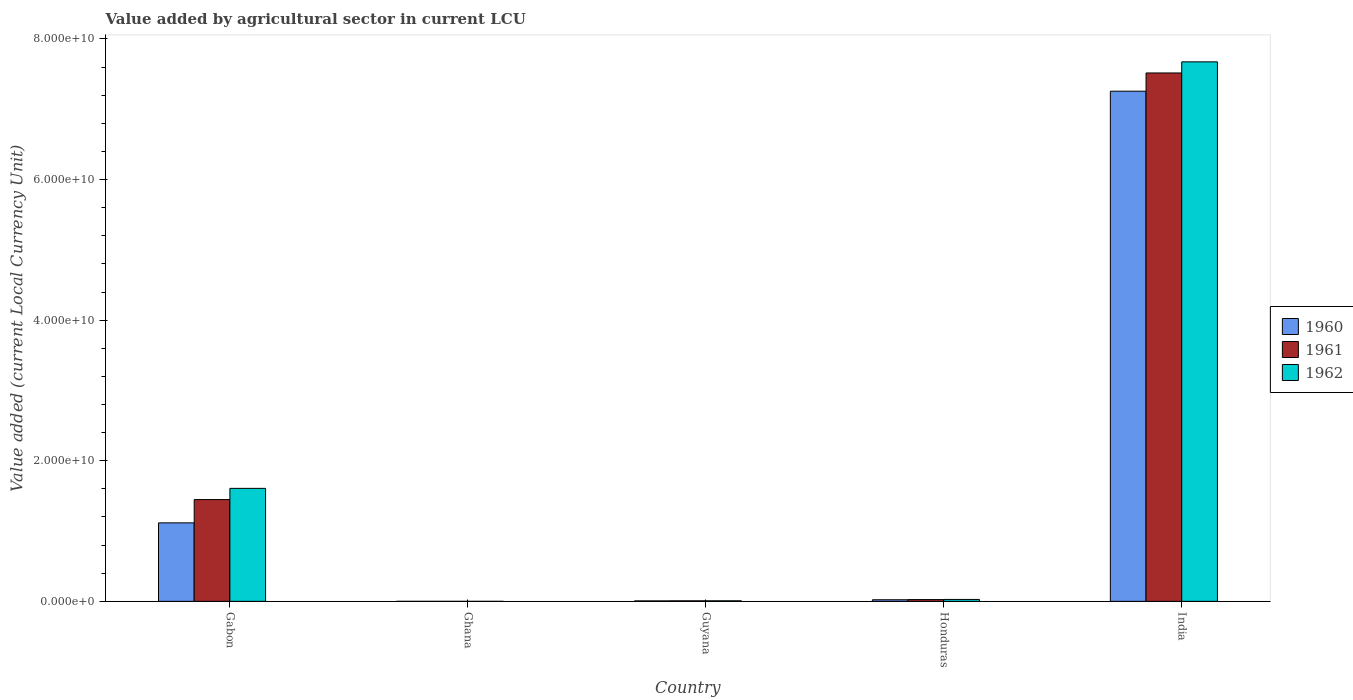Are the number of bars per tick equal to the number of legend labels?
Offer a very short reply. Yes. Are the number of bars on each tick of the X-axis equal?
Keep it short and to the point. Yes. What is the label of the 1st group of bars from the left?
Give a very brief answer. Gabon. In how many cases, is the number of bars for a given country not equal to the number of legend labels?
Ensure brevity in your answer.  0. What is the value added by agricultural sector in 1960 in Guyana?
Make the answer very short. 6.88e+07. Across all countries, what is the maximum value added by agricultural sector in 1961?
Your answer should be very brief. 7.52e+1. Across all countries, what is the minimum value added by agricultural sector in 1962?
Offer a very short reply. 3.74e+04. What is the total value added by agricultural sector in 1961 in the graph?
Your response must be concise. 9.00e+1. What is the difference between the value added by agricultural sector in 1961 in Ghana and that in Guyana?
Provide a short and direct response. -7.60e+07. What is the difference between the value added by agricultural sector in 1962 in India and the value added by agricultural sector in 1961 in Guyana?
Give a very brief answer. 7.67e+1. What is the average value added by agricultural sector in 1960 per country?
Provide a succinct answer. 1.68e+1. What is the difference between the value added by agricultural sector of/in 1962 and value added by agricultural sector of/in 1961 in Guyana?
Ensure brevity in your answer.  2.40e+06. In how many countries, is the value added by agricultural sector in 1960 greater than 24000000000 LCU?
Your answer should be very brief. 1. What is the ratio of the value added by agricultural sector in 1960 in Gabon to that in Honduras?
Offer a very short reply. 49.18. Is the value added by agricultural sector in 1960 in Ghana less than that in Guyana?
Ensure brevity in your answer.  Yes. Is the difference between the value added by agricultural sector in 1962 in Gabon and Ghana greater than the difference between the value added by agricultural sector in 1961 in Gabon and Ghana?
Offer a terse response. Yes. What is the difference between the highest and the second highest value added by agricultural sector in 1962?
Your answer should be compact. 6.07e+1. What is the difference between the highest and the lowest value added by agricultural sector in 1962?
Provide a short and direct response. 7.67e+1. In how many countries, is the value added by agricultural sector in 1960 greater than the average value added by agricultural sector in 1960 taken over all countries?
Offer a very short reply. 1. Is the sum of the value added by agricultural sector in 1960 in Guyana and India greater than the maximum value added by agricultural sector in 1962 across all countries?
Your answer should be compact. No. What does the 3rd bar from the left in Honduras represents?
Your answer should be very brief. 1962. Is it the case that in every country, the sum of the value added by agricultural sector in 1962 and value added by agricultural sector in 1960 is greater than the value added by agricultural sector in 1961?
Your answer should be compact. Yes. How many bars are there?
Your answer should be compact. 15. Are all the bars in the graph horizontal?
Keep it short and to the point. No. How many countries are there in the graph?
Ensure brevity in your answer.  5. Are the values on the major ticks of Y-axis written in scientific E-notation?
Make the answer very short. Yes. Does the graph contain grids?
Provide a succinct answer. No. How many legend labels are there?
Your answer should be compact. 3. What is the title of the graph?
Your response must be concise. Value added by agricultural sector in current LCU. Does "2011" appear as one of the legend labels in the graph?
Ensure brevity in your answer.  No. What is the label or title of the Y-axis?
Your answer should be compact. Value added (current Local Currency Unit). What is the Value added (current Local Currency Unit) of 1960 in Gabon?
Provide a short and direct response. 1.12e+1. What is the Value added (current Local Currency Unit) of 1961 in Gabon?
Provide a short and direct response. 1.45e+1. What is the Value added (current Local Currency Unit) of 1962 in Gabon?
Provide a short and direct response. 1.61e+1. What is the Value added (current Local Currency Unit) in 1960 in Ghana?
Provide a short and direct response. 3.55e+04. What is the Value added (current Local Currency Unit) in 1961 in Ghana?
Your response must be concise. 3.29e+04. What is the Value added (current Local Currency Unit) of 1962 in Ghana?
Your answer should be very brief. 3.74e+04. What is the Value added (current Local Currency Unit) of 1960 in Guyana?
Offer a terse response. 6.88e+07. What is the Value added (current Local Currency Unit) in 1961 in Guyana?
Provide a short and direct response. 7.60e+07. What is the Value added (current Local Currency Unit) of 1962 in Guyana?
Keep it short and to the point. 7.84e+07. What is the Value added (current Local Currency Unit) in 1960 in Honduras?
Provide a short and direct response. 2.27e+08. What is the Value added (current Local Currency Unit) in 1961 in Honduras?
Your answer should be compact. 2.51e+08. What is the Value added (current Local Currency Unit) of 1962 in Honduras?
Ensure brevity in your answer.  2.74e+08. What is the Value added (current Local Currency Unit) of 1960 in India?
Provide a succinct answer. 7.26e+1. What is the Value added (current Local Currency Unit) in 1961 in India?
Make the answer very short. 7.52e+1. What is the Value added (current Local Currency Unit) of 1962 in India?
Make the answer very short. 7.67e+1. Across all countries, what is the maximum Value added (current Local Currency Unit) in 1960?
Offer a terse response. 7.26e+1. Across all countries, what is the maximum Value added (current Local Currency Unit) in 1961?
Your response must be concise. 7.52e+1. Across all countries, what is the maximum Value added (current Local Currency Unit) in 1962?
Ensure brevity in your answer.  7.67e+1. Across all countries, what is the minimum Value added (current Local Currency Unit) of 1960?
Provide a succinct answer. 3.55e+04. Across all countries, what is the minimum Value added (current Local Currency Unit) in 1961?
Provide a short and direct response. 3.29e+04. Across all countries, what is the minimum Value added (current Local Currency Unit) of 1962?
Your answer should be compact. 3.74e+04. What is the total Value added (current Local Currency Unit) of 1960 in the graph?
Offer a very short reply. 8.40e+1. What is the total Value added (current Local Currency Unit) in 1961 in the graph?
Your response must be concise. 9.00e+1. What is the total Value added (current Local Currency Unit) in 1962 in the graph?
Make the answer very short. 9.32e+1. What is the difference between the Value added (current Local Currency Unit) of 1960 in Gabon and that in Ghana?
Make the answer very short. 1.12e+1. What is the difference between the Value added (current Local Currency Unit) of 1961 in Gabon and that in Ghana?
Your answer should be very brief. 1.45e+1. What is the difference between the Value added (current Local Currency Unit) in 1962 in Gabon and that in Ghana?
Give a very brief answer. 1.61e+1. What is the difference between the Value added (current Local Currency Unit) in 1960 in Gabon and that in Guyana?
Provide a short and direct response. 1.11e+1. What is the difference between the Value added (current Local Currency Unit) in 1961 in Gabon and that in Guyana?
Your response must be concise. 1.44e+1. What is the difference between the Value added (current Local Currency Unit) in 1962 in Gabon and that in Guyana?
Keep it short and to the point. 1.60e+1. What is the difference between the Value added (current Local Currency Unit) of 1960 in Gabon and that in Honduras?
Provide a succinct answer. 1.09e+1. What is the difference between the Value added (current Local Currency Unit) of 1961 in Gabon and that in Honduras?
Keep it short and to the point. 1.42e+1. What is the difference between the Value added (current Local Currency Unit) of 1962 in Gabon and that in Honduras?
Offer a very short reply. 1.58e+1. What is the difference between the Value added (current Local Currency Unit) in 1960 in Gabon and that in India?
Offer a very short reply. -6.14e+1. What is the difference between the Value added (current Local Currency Unit) in 1961 in Gabon and that in India?
Provide a succinct answer. -6.07e+1. What is the difference between the Value added (current Local Currency Unit) in 1962 in Gabon and that in India?
Give a very brief answer. -6.07e+1. What is the difference between the Value added (current Local Currency Unit) in 1960 in Ghana and that in Guyana?
Make the answer very short. -6.88e+07. What is the difference between the Value added (current Local Currency Unit) of 1961 in Ghana and that in Guyana?
Make the answer very short. -7.60e+07. What is the difference between the Value added (current Local Currency Unit) in 1962 in Ghana and that in Guyana?
Your response must be concise. -7.84e+07. What is the difference between the Value added (current Local Currency Unit) of 1960 in Ghana and that in Honduras?
Ensure brevity in your answer.  -2.27e+08. What is the difference between the Value added (current Local Currency Unit) of 1961 in Ghana and that in Honduras?
Keep it short and to the point. -2.51e+08. What is the difference between the Value added (current Local Currency Unit) of 1962 in Ghana and that in Honduras?
Make the answer very short. -2.74e+08. What is the difference between the Value added (current Local Currency Unit) in 1960 in Ghana and that in India?
Your response must be concise. -7.26e+1. What is the difference between the Value added (current Local Currency Unit) of 1961 in Ghana and that in India?
Offer a terse response. -7.52e+1. What is the difference between the Value added (current Local Currency Unit) in 1962 in Ghana and that in India?
Offer a very short reply. -7.67e+1. What is the difference between the Value added (current Local Currency Unit) of 1960 in Guyana and that in Honduras?
Provide a short and direct response. -1.58e+08. What is the difference between the Value added (current Local Currency Unit) in 1961 in Guyana and that in Honduras?
Offer a very short reply. -1.75e+08. What is the difference between the Value added (current Local Currency Unit) in 1962 in Guyana and that in Honduras?
Offer a very short reply. -1.96e+08. What is the difference between the Value added (current Local Currency Unit) of 1960 in Guyana and that in India?
Offer a terse response. -7.25e+1. What is the difference between the Value added (current Local Currency Unit) of 1961 in Guyana and that in India?
Provide a succinct answer. -7.51e+1. What is the difference between the Value added (current Local Currency Unit) in 1962 in Guyana and that in India?
Ensure brevity in your answer.  -7.67e+1. What is the difference between the Value added (current Local Currency Unit) of 1960 in Honduras and that in India?
Your answer should be compact. -7.23e+1. What is the difference between the Value added (current Local Currency Unit) in 1961 in Honduras and that in India?
Keep it short and to the point. -7.49e+1. What is the difference between the Value added (current Local Currency Unit) in 1962 in Honduras and that in India?
Offer a terse response. -7.65e+1. What is the difference between the Value added (current Local Currency Unit) in 1960 in Gabon and the Value added (current Local Currency Unit) in 1961 in Ghana?
Offer a terse response. 1.12e+1. What is the difference between the Value added (current Local Currency Unit) in 1960 in Gabon and the Value added (current Local Currency Unit) in 1962 in Ghana?
Provide a succinct answer. 1.12e+1. What is the difference between the Value added (current Local Currency Unit) of 1961 in Gabon and the Value added (current Local Currency Unit) of 1962 in Ghana?
Make the answer very short. 1.45e+1. What is the difference between the Value added (current Local Currency Unit) of 1960 in Gabon and the Value added (current Local Currency Unit) of 1961 in Guyana?
Offer a very short reply. 1.11e+1. What is the difference between the Value added (current Local Currency Unit) of 1960 in Gabon and the Value added (current Local Currency Unit) of 1962 in Guyana?
Your answer should be very brief. 1.11e+1. What is the difference between the Value added (current Local Currency Unit) of 1961 in Gabon and the Value added (current Local Currency Unit) of 1962 in Guyana?
Offer a terse response. 1.44e+1. What is the difference between the Value added (current Local Currency Unit) in 1960 in Gabon and the Value added (current Local Currency Unit) in 1961 in Honduras?
Ensure brevity in your answer.  1.09e+1. What is the difference between the Value added (current Local Currency Unit) of 1960 in Gabon and the Value added (current Local Currency Unit) of 1962 in Honduras?
Offer a terse response. 1.09e+1. What is the difference between the Value added (current Local Currency Unit) in 1961 in Gabon and the Value added (current Local Currency Unit) in 1962 in Honduras?
Your answer should be compact. 1.42e+1. What is the difference between the Value added (current Local Currency Unit) in 1960 in Gabon and the Value added (current Local Currency Unit) in 1961 in India?
Your answer should be compact. -6.40e+1. What is the difference between the Value added (current Local Currency Unit) of 1960 in Gabon and the Value added (current Local Currency Unit) of 1962 in India?
Your answer should be compact. -6.56e+1. What is the difference between the Value added (current Local Currency Unit) in 1961 in Gabon and the Value added (current Local Currency Unit) in 1962 in India?
Your response must be concise. -6.23e+1. What is the difference between the Value added (current Local Currency Unit) of 1960 in Ghana and the Value added (current Local Currency Unit) of 1961 in Guyana?
Keep it short and to the point. -7.60e+07. What is the difference between the Value added (current Local Currency Unit) in 1960 in Ghana and the Value added (current Local Currency Unit) in 1962 in Guyana?
Provide a short and direct response. -7.84e+07. What is the difference between the Value added (current Local Currency Unit) in 1961 in Ghana and the Value added (current Local Currency Unit) in 1962 in Guyana?
Offer a very short reply. -7.84e+07. What is the difference between the Value added (current Local Currency Unit) in 1960 in Ghana and the Value added (current Local Currency Unit) in 1961 in Honduras?
Offer a terse response. -2.51e+08. What is the difference between the Value added (current Local Currency Unit) of 1960 in Ghana and the Value added (current Local Currency Unit) of 1962 in Honduras?
Provide a short and direct response. -2.74e+08. What is the difference between the Value added (current Local Currency Unit) of 1961 in Ghana and the Value added (current Local Currency Unit) of 1962 in Honduras?
Your answer should be compact. -2.74e+08. What is the difference between the Value added (current Local Currency Unit) of 1960 in Ghana and the Value added (current Local Currency Unit) of 1961 in India?
Your response must be concise. -7.52e+1. What is the difference between the Value added (current Local Currency Unit) in 1960 in Ghana and the Value added (current Local Currency Unit) in 1962 in India?
Your answer should be compact. -7.67e+1. What is the difference between the Value added (current Local Currency Unit) in 1961 in Ghana and the Value added (current Local Currency Unit) in 1962 in India?
Your answer should be compact. -7.67e+1. What is the difference between the Value added (current Local Currency Unit) in 1960 in Guyana and the Value added (current Local Currency Unit) in 1961 in Honduras?
Provide a short and direct response. -1.82e+08. What is the difference between the Value added (current Local Currency Unit) of 1960 in Guyana and the Value added (current Local Currency Unit) of 1962 in Honduras?
Keep it short and to the point. -2.06e+08. What is the difference between the Value added (current Local Currency Unit) of 1961 in Guyana and the Value added (current Local Currency Unit) of 1962 in Honduras?
Give a very brief answer. -1.98e+08. What is the difference between the Value added (current Local Currency Unit) in 1960 in Guyana and the Value added (current Local Currency Unit) in 1961 in India?
Your answer should be compact. -7.51e+1. What is the difference between the Value added (current Local Currency Unit) in 1960 in Guyana and the Value added (current Local Currency Unit) in 1962 in India?
Your answer should be very brief. -7.67e+1. What is the difference between the Value added (current Local Currency Unit) of 1961 in Guyana and the Value added (current Local Currency Unit) of 1962 in India?
Your answer should be very brief. -7.67e+1. What is the difference between the Value added (current Local Currency Unit) in 1960 in Honduras and the Value added (current Local Currency Unit) in 1961 in India?
Your answer should be compact. -7.49e+1. What is the difference between the Value added (current Local Currency Unit) of 1960 in Honduras and the Value added (current Local Currency Unit) of 1962 in India?
Make the answer very short. -7.65e+1. What is the difference between the Value added (current Local Currency Unit) in 1961 in Honduras and the Value added (current Local Currency Unit) in 1962 in India?
Provide a short and direct response. -7.65e+1. What is the average Value added (current Local Currency Unit) in 1960 per country?
Offer a terse response. 1.68e+1. What is the average Value added (current Local Currency Unit) of 1961 per country?
Your answer should be compact. 1.80e+1. What is the average Value added (current Local Currency Unit) of 1962 per country?
Your answer should be compact. 1.86e+1. What is the difference between the Value added (current Local Currency Unit) in 1960 and Value added (current Local Currency Unit) in 1961 in Gabon?
Make the answer very short. -3.31e+09. What is the difference between the Value added (current Local Currency Unit) in 1960 and Value added (current Local Currency Unit) in 1962 in Gabon?
Your answer should be very brief. -4.91e+09. What is the difference between the Value added (current Local Currency Unit) in 1961 and Value added (current Local Currency Unit) in 1962 in Gabon?
Offer a very short reply. -1.59e+09. What is the difference between the Value added (current Local Currency Unit) of 1960 and Value added (current Local Currency Unit) of 1961 in Ghana?
Make the answer very short. 2600. What is the difference between the Value added (current Local Currency Unit) of 1960 and Value added (current Local Currency Unit) of 1962 in Ghana?
Your answer should be very brief. -1900. What is the difference between the Value added (current Local Currency Unit) in 1961 and Value added (current Local Currency Unit) in 1962 in Ghana?
Your answer should be very brief. -4500. What is the difference between the Value added (current Local Currency Unit) of 1960 and Value added (current Local Currency Unit) of 1961 in Guyana?
Provide a short and direct response. -7.20e+06. What is the difference between the Value added (current Local Currency Unit) of 1960 and Value added (current Local Currency Unit) of 1962 in Guyana?
Your answer should be very brief. -9.60e+06. What is the difference between the Value added (current Local Currency Unit) in 1961 and Value added (current Local Currency Unit) in 1962 in Guyana?
Ensure brevity in your answer.  -2.40e+06. What is the difference between the Value added (current Local Currency Unit) of 1960 and Value added (current Local Currency Unit) of 1961 in Honduras?
Provide a short and direct response. -2.42e+07. What is the difference between the Value added (current Local Currency Unit) in 1960 and Value added (current Local Currency Unit) in 1962 in Honduras?
Keep it short and to the point. -4.75e+07. What is the difference between the Value added (current Local Currency Unit) in 1961 and Value added (current Local Currency Unit) in 1962 in Honduras?
Offer a terse response. -2.33e+07. What is the difference between the Value added (current Local Currency Unit) of 1960 and Value added (current Local Currency Unit) of 1961 in India?
Your answer should be very brief. -2.59e+09. What is the difference between the Value added (current Local Currency Unit) in 1960 and Value added (current Local Currency Unit) in 1962 in India?
Provide a short and direct response. -4.17e+09. What is the difference between the Value added (current Local Currency Unit) of 1961 and Value added (current Local Currency Unit) of 1962 in India?
Give a very brief answer. -1.58e+09. What is the ratio of the Value added (current Local Currency Unit) in 1960 in Gabon to that in Ghana?
Provide a succinct answer. 3.14e+05. What is the ratio of the Value added (current Local Currency Unit) in 1961 in Gabon to that in Ghana?
Provide a short and direct response. 4.40e+05. What is the ratio of the Value added (current Local Currency Unit) of 1962 in Gabon to that in Ghana?
Your answer should be very brief. 4.30e+05. What is the ratio of the Value added (current Local Currency Unit) of 1960 in Gabon to that in Guyana?
Keep it short and to the point. 162.28. What is the ratio of the Value added (current Local Currency Unit) of 1961 in Gabon to that in Guyana?
Make the answer very short. 190.49. What is the ratio of the Value added (current Local Currency Unit) in 1962 in Gabon to that in Guyana?
Make the answer very short. 205. What is the ratio of the Value added (current Local Currency Unit) of 1960 in Gabon to that in Honduras?
Ensure brevity in your answer.  49.18. What is the ratio of the Value added (current Local Currency Unit) of 1961 in Gabon to that in Honduras?
Keep it short and to the point. 57.63. What is the ratio of the Value added (current Local Currency Unit) in 1962 in Gabon to that in Honduras?
Offer a very short reply. 58.55. What is the ratio of the Value added (current Local Currency Unit) in 1960 in Gabon to that in India?
Provide a short and direct response. 0.15. What is the ratio of the Value added (current Local Currency Unit) of 1961 in Gabon to that in India?
Keep it short and to the point. 0.19. What is the ratio of the Value added (current Local Currency Unit) in 1962 in Gabon to that in India?
Your response must be concise. 0.21. What is the ratio of the Value added (current Local Currency Unit) of 1962 in Ghana to that in Guyana?
Offer a terse response. 0. What is the ratio of the Value added (current Local Currency Unit) of 1962 in Ghana to that in India?
Make the answer very short. 0. What is the ratio of the Value added (current Local Currency Unit) of 1960 in Guyana to that in Honduras?
Your answer should be very brief. 0.3. What is the ratio of the Value added (current Local Currency Unit) of 1961 in Guyana to that in Honduras?
Keep it short and to the point. 0.3. What is the ratio of the Value added (current Local Currency Unit) in 1962 in Guyana to that in Honduras?
Your response must be concise. 0.29. What is the ratio of the Value added (current Local Currency Unit) of 1960 in Guyana to that in India?
Keep it short and to the point. 0. What is the ratio of the Value added (current Local Currency Unit) of 1960 in Honduras to that in India?
Offer a very short reply. 0. What is the ratio of the Value added (current Local Currency Unit) in 1961 in Honduras to that in India?
Provide a short and direct response. 0. What is the ratio of the Value added (current Local Currency Unit) of 1962 in Honduras to that in India?
Offer a terse response. 0. What is the difference between the highest and the second highest Value added (current Local Currency Unit) of 1960?
Ensure brevity in your answer.  6.14e+1. What is the difference between the highest and the second highest Value added (current Local Currency Unit) of 1961?
Offer a very short reply. 6.07e+1. What is the difference between the highest and the second highest Value added (current Local Currency Unit) of 1962?
Your answer should be very brief. 6.07e+1. What is the difference between the highest and the lowest Value added (current Local Currency Unit) in 1960?
Provide a succinct answer. 7.26e+1. What is the difference between the highest and the lowest Value added (current Local Currency Unit) in 1961?
Keep it short and to the point. 7.52e+1. What is the difference between the highest and the lowest Value added (current Local Currency Unit) in 1962?
Offer a very short reply. 7.67e+1. 